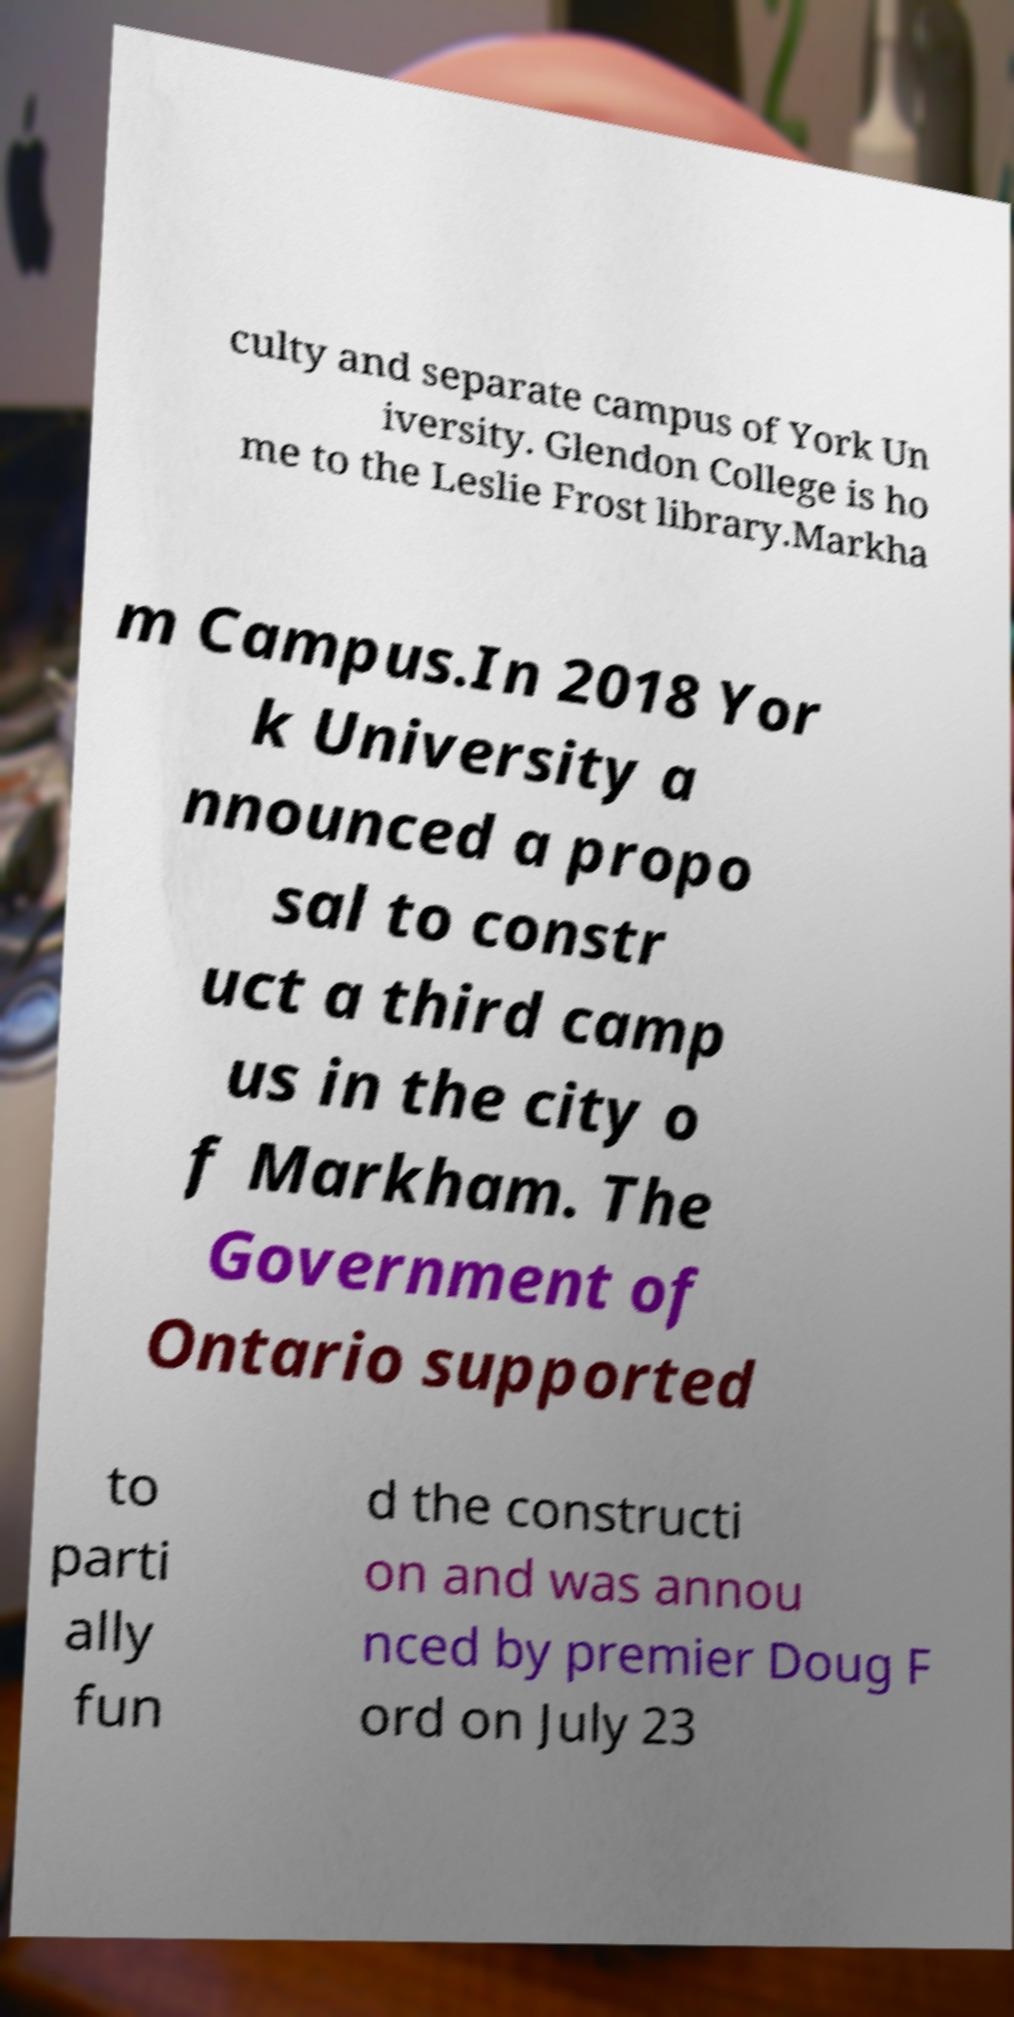What messages or text are displayed in this image? I need them in a readable, typed format. culty and separate campus of York Un iversity. Glendon College is ho me to the Leslie Frost library.Markha m Campus.In 2018 Yor k University a nnounced a propo sal to constr uct a third camp us in the city o f Markham. The Government of Ontario supported to parti ally fun d the constructi on and was annou nced by premier Doug F ord on July 23 